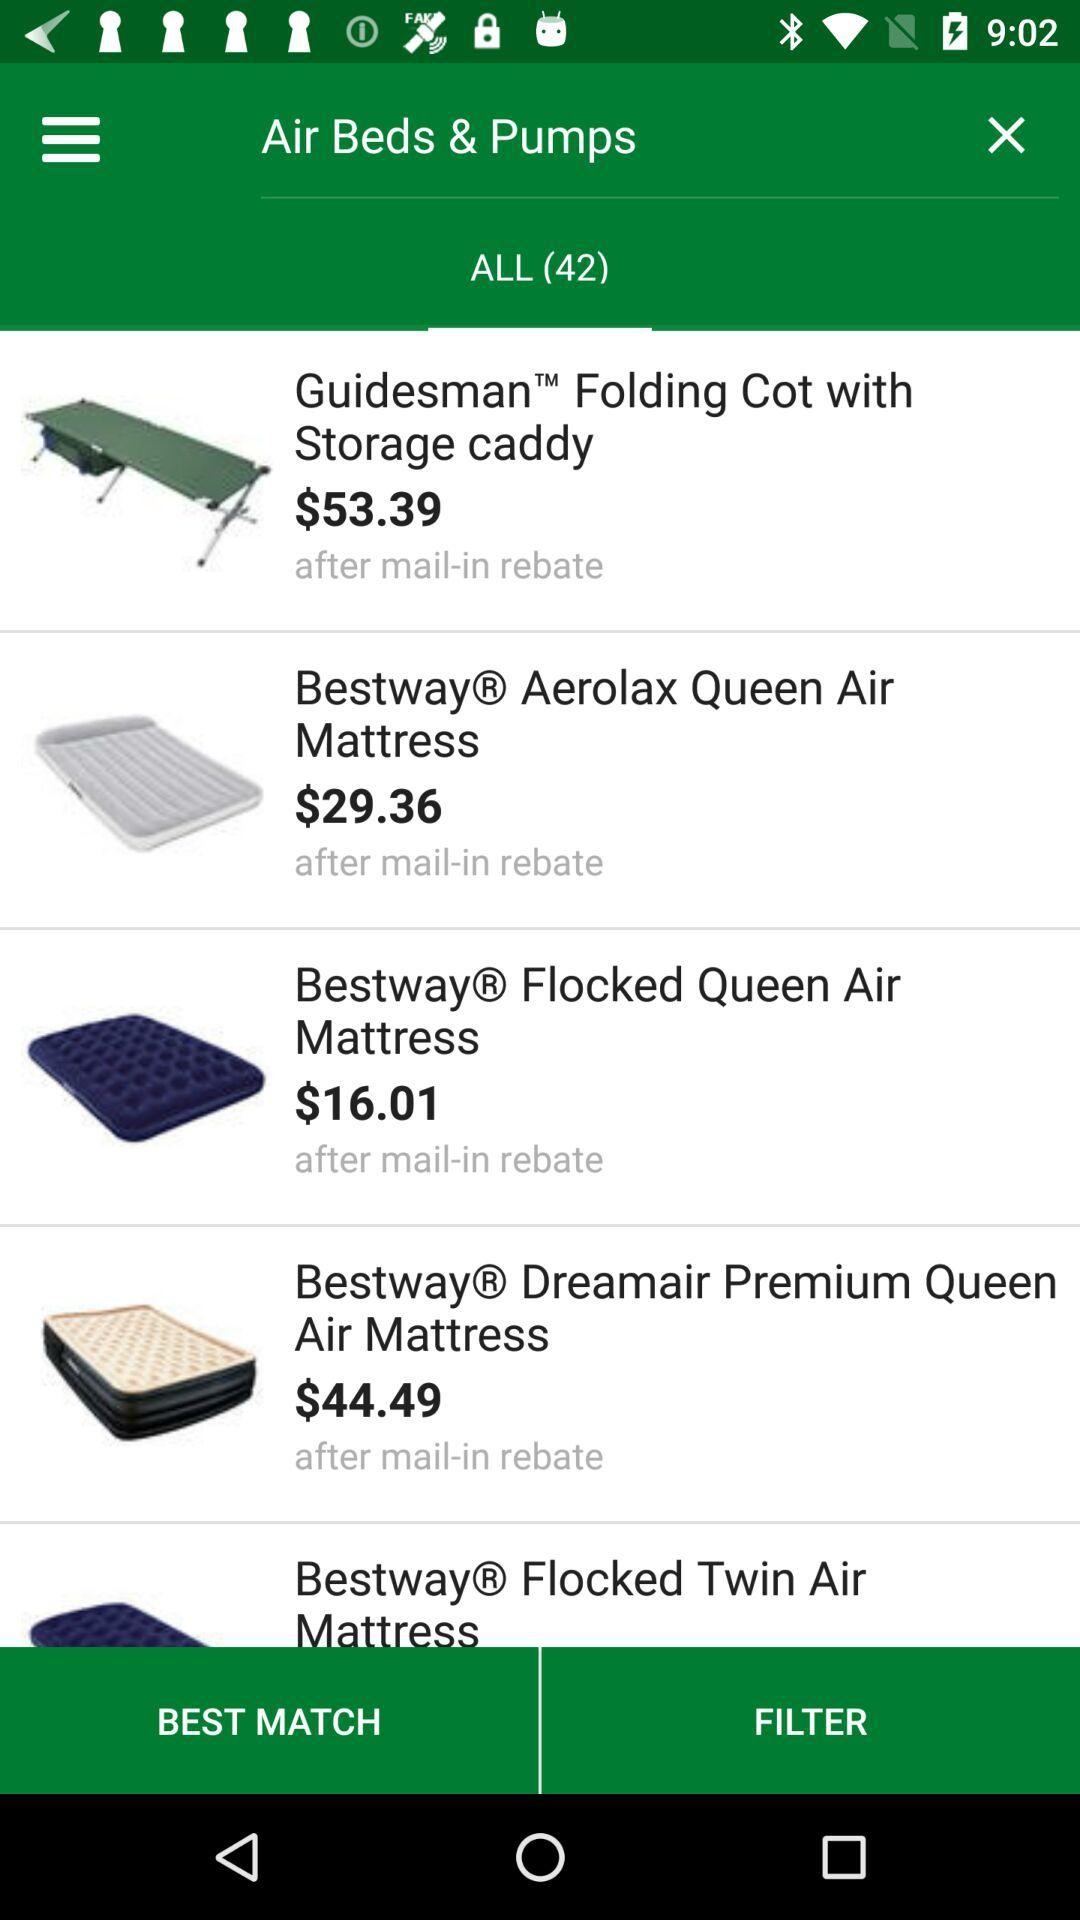How many air beds and pumps are on sale?
Answer the question using a single word or phrase. 42 